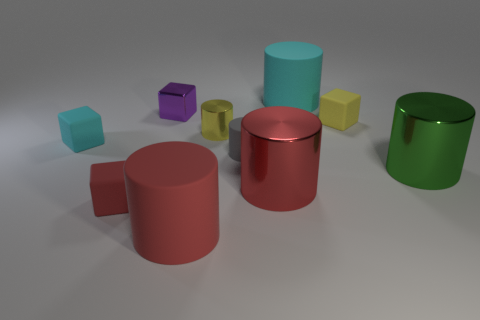Subtract all red cylinders. How many were subtracted if there are1red cylinders left? 1 Subtract all metal blocks. How many blocks are left? 3 Subtract all yellow cubes. How many cubes are left? 3 Subtract all cylinders. How many objects are left? 4 Subtract all red blocks. Subtract all purple spheres. How many blocks are left? 3 Subtract all gray cylinders. How many gray cubes are left? 0 Subtract all blue cylinders. Subtract all small red rubber cubes. How many objects are left? 9 Add 1 cylinders. How many cylinders are left? 7 Add 6 large gray metal cylinders. How many large gray metal cylinders exist? 6 Subtract 0 red spheres. How many objects are left? 10 